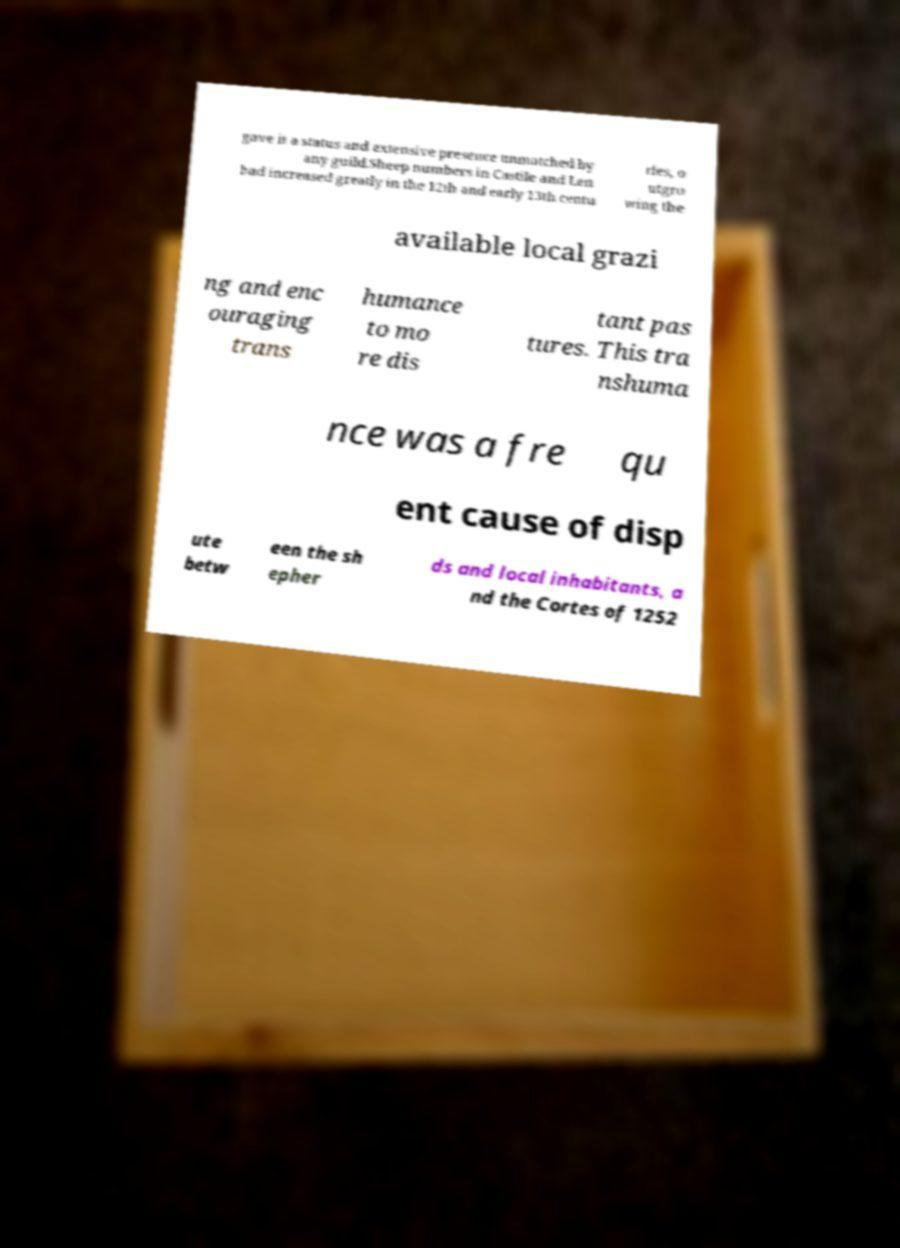What messages or text are displayed in this image? I need them in a readable, typed format. gave it a status and extensive presence unmatched by any guild.Sheep numbers in Castile and Len had increased greatly in the 12th and early 13th centu ries, o utgro wing the available local grazi ng and enc ouraging trans humance to mo re dis tant pas tures. This tra nshuma nce was a fre qu ent cause of disp ute betw een the sh epher ds and local inhabitants, a nd the Cortes of 1252 